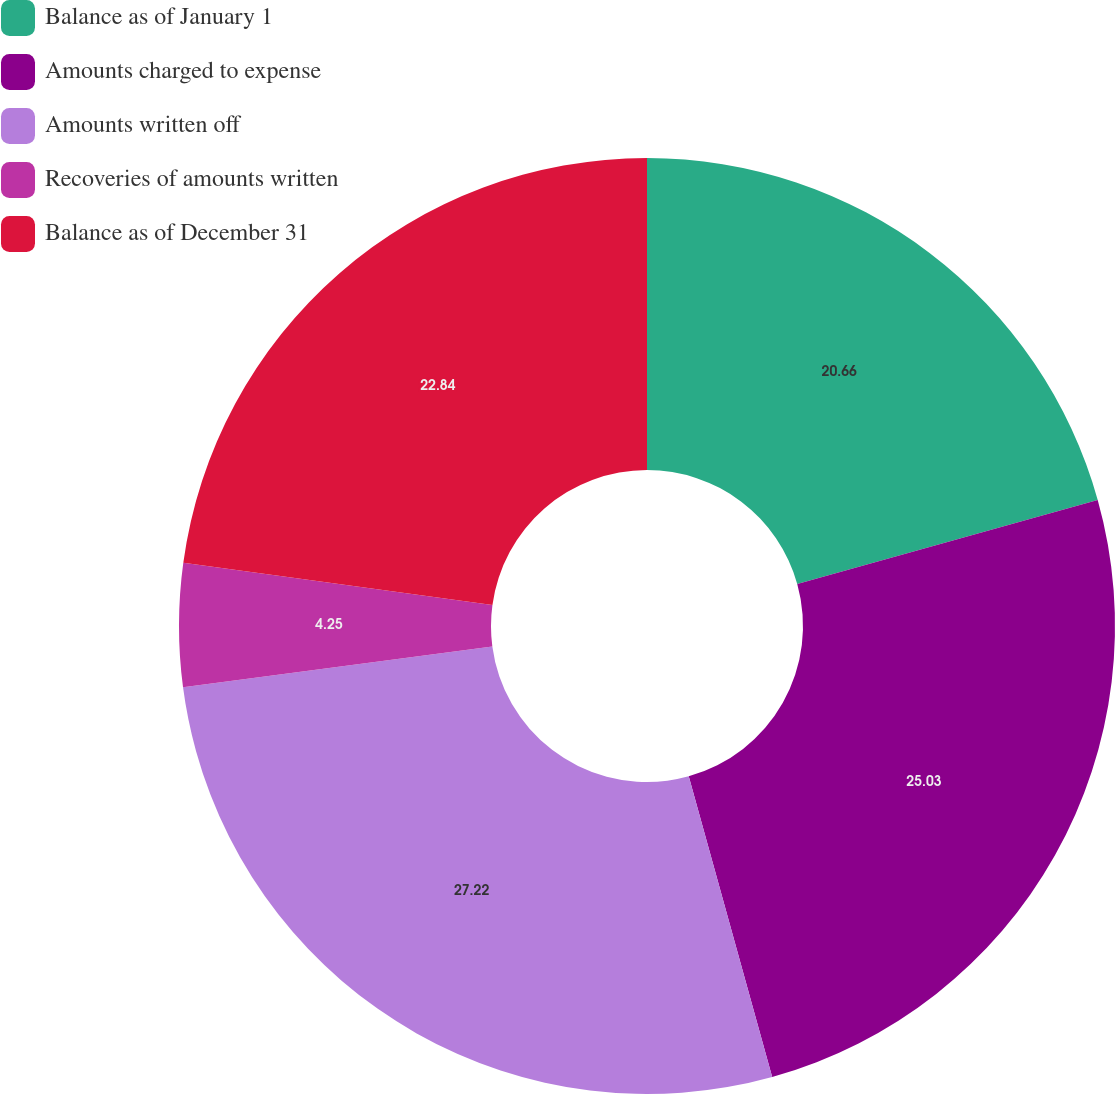Convert chart. <chart><loc_0><loc_0><loc_500><loc_500><pie_chart><fcel>Balance as of January 1<fcel>Amounts charged to expense<fcel>Amounts written off<fcel>Recoveries of amounts written<fcel>Balance as of December 31<nl><fcel>20.66%<fcel>25.03%<fcel>27.22%<fcel>4.25%<fcel>22.84%<nl></chart> 